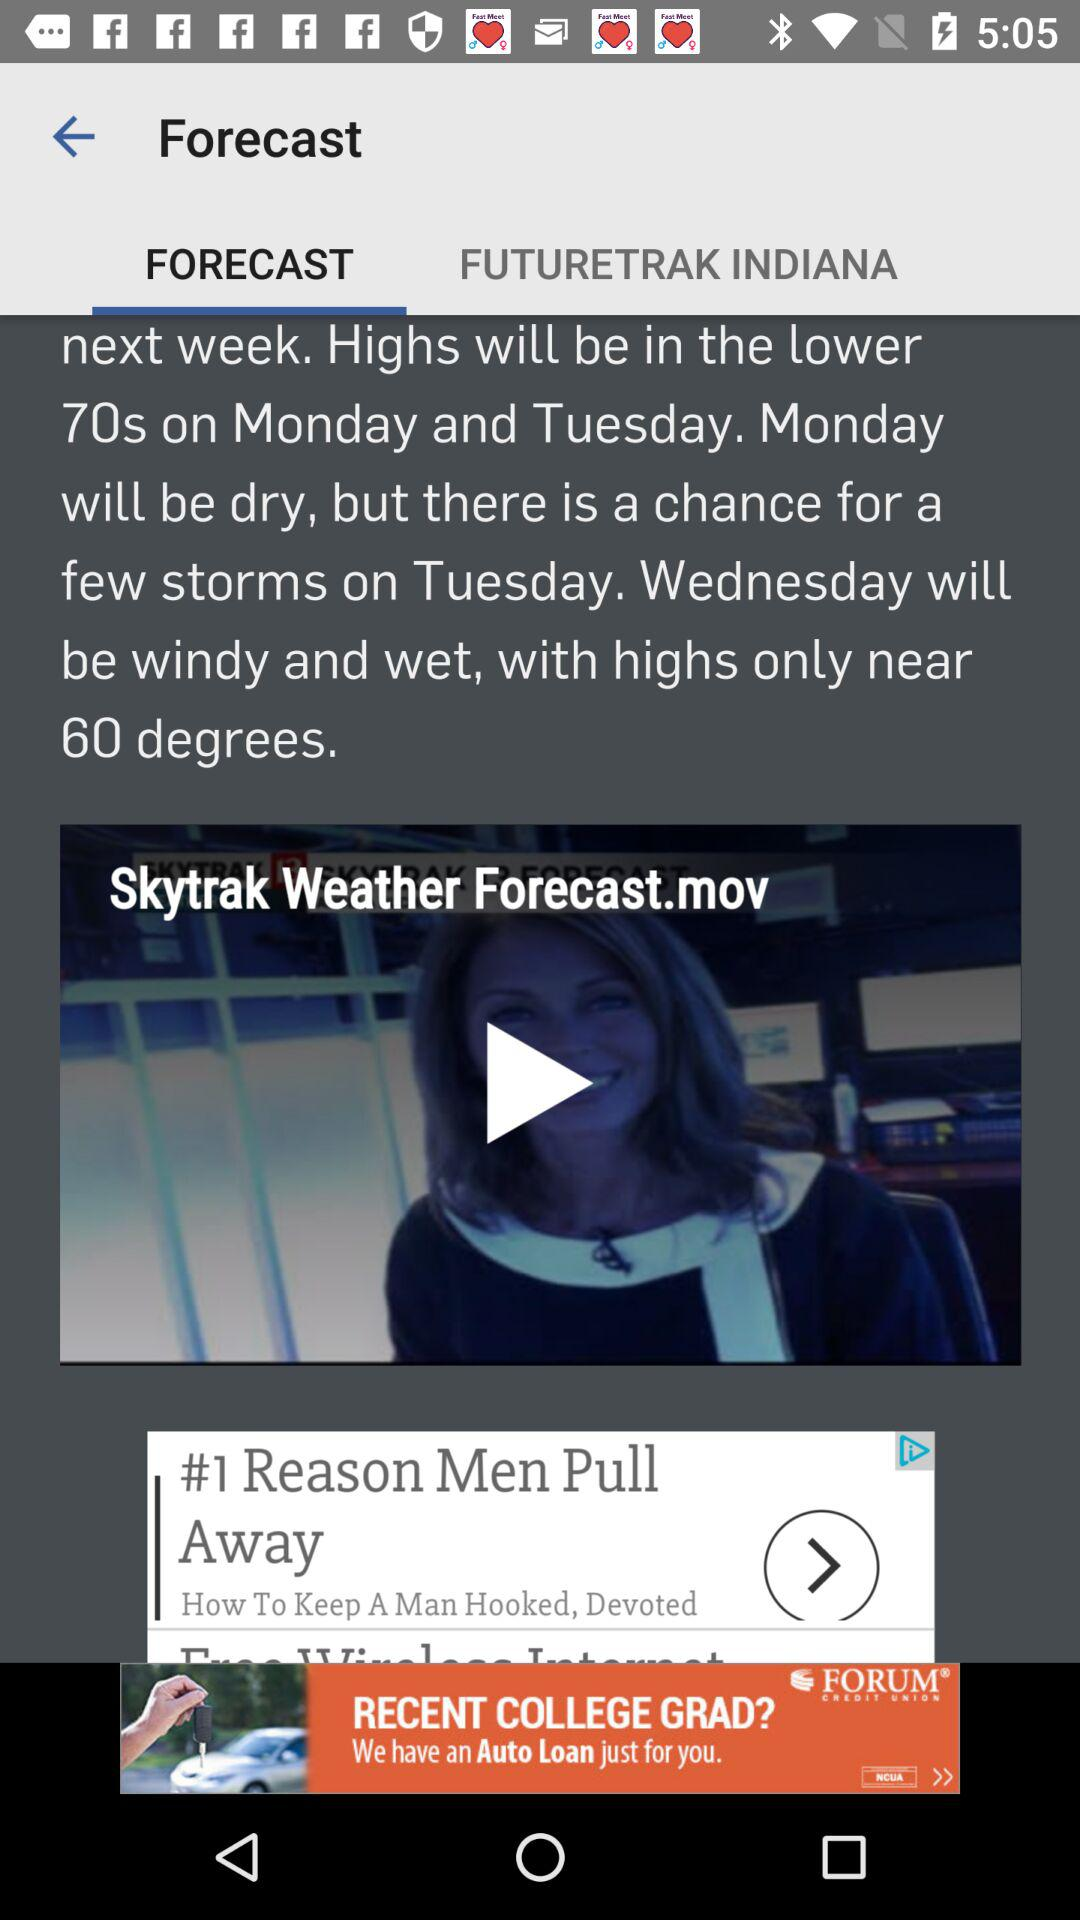How many degrees higher will the high be on Monday than on Wednesday?
Answer the question using a single word or phrase. 10 